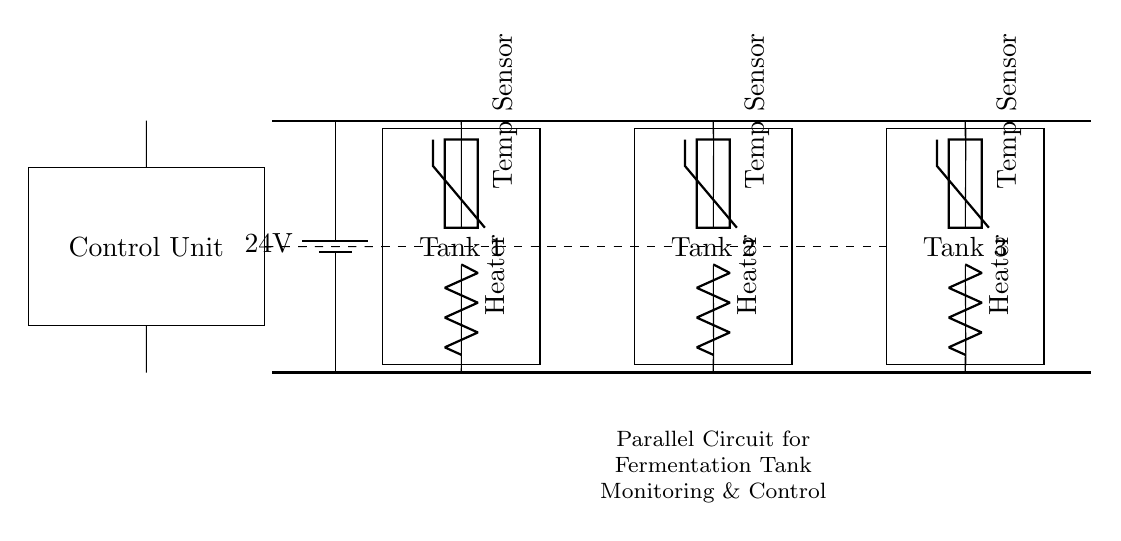What is the supply voltage for this circuit? The supply voltage is 24 volts, which is indicated by the battery component in the circuit.
Answer: 24 volts What type of sensors are used in the tanks? The sensors used in the tanks are thermistors, as labeled in the circuit diagram near each tank.
Answer: Thermistor How many fermentation tanks are being monitored in this circuit? There are three fermentation tanks shown in the diagram, as represented by the three rectangles labeled Tank 1, Tank 2, and Tank 3.
Answer: Three What is connected to the bottom of each fermentation tank? A heater is connected to the bottom of each tank, indicated by the resistor component labeled Heater in the diagram.
Answer: Heater What function does the control unit serve in this circuit? The control unit is responsible for monitoring and controlling the temperature readings from the sensors and managing the heaters for each tank.
Answer: Monitoring and controlling In what configuration are the fermentation tanks connected in this circuit? The fermentation tanks are connected in parallel, allowing each tank to operate independently while sharing the same voltage supply.
Answer: Parallel 